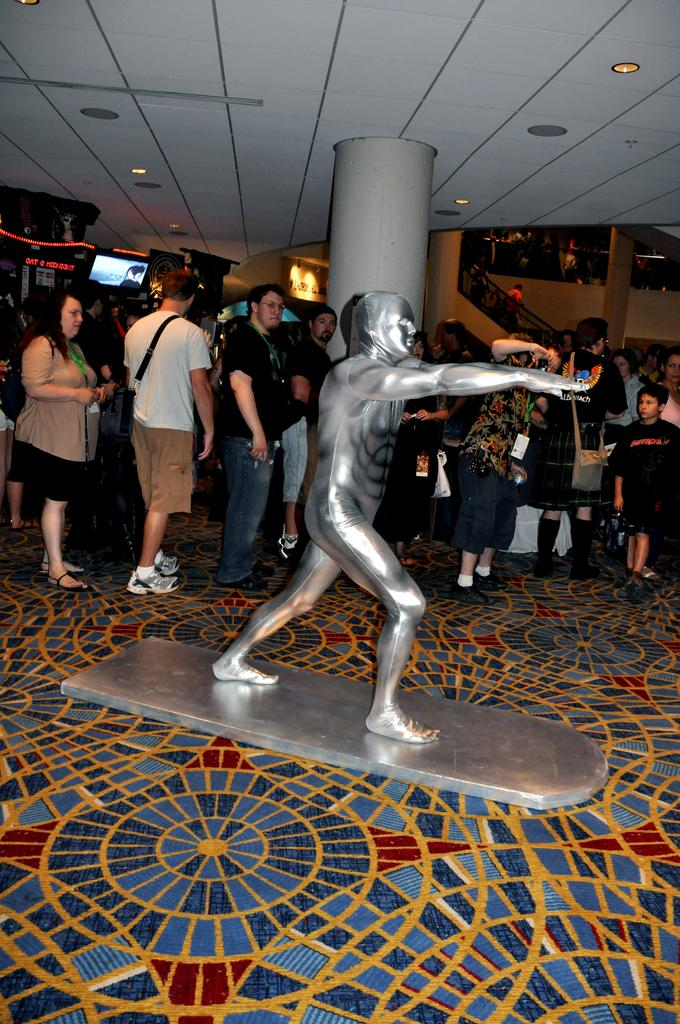What is the main subject in the middle of the image? There is a statue in the middle of the image. What are the people in the image doing? The people are standing behind the statue and watching it. What can be seen at the top of the image? There is a roof visible at the top of the image, and there are lights present as well. Can you tell me how many matches are being played in the image? There is no reference to any matches or sports events in the image; it features a statue with people watching it. What type of patch is visible on the statue's clothing? The statue does not have clothing, and therefore no patches are present. 